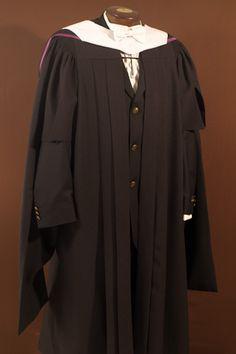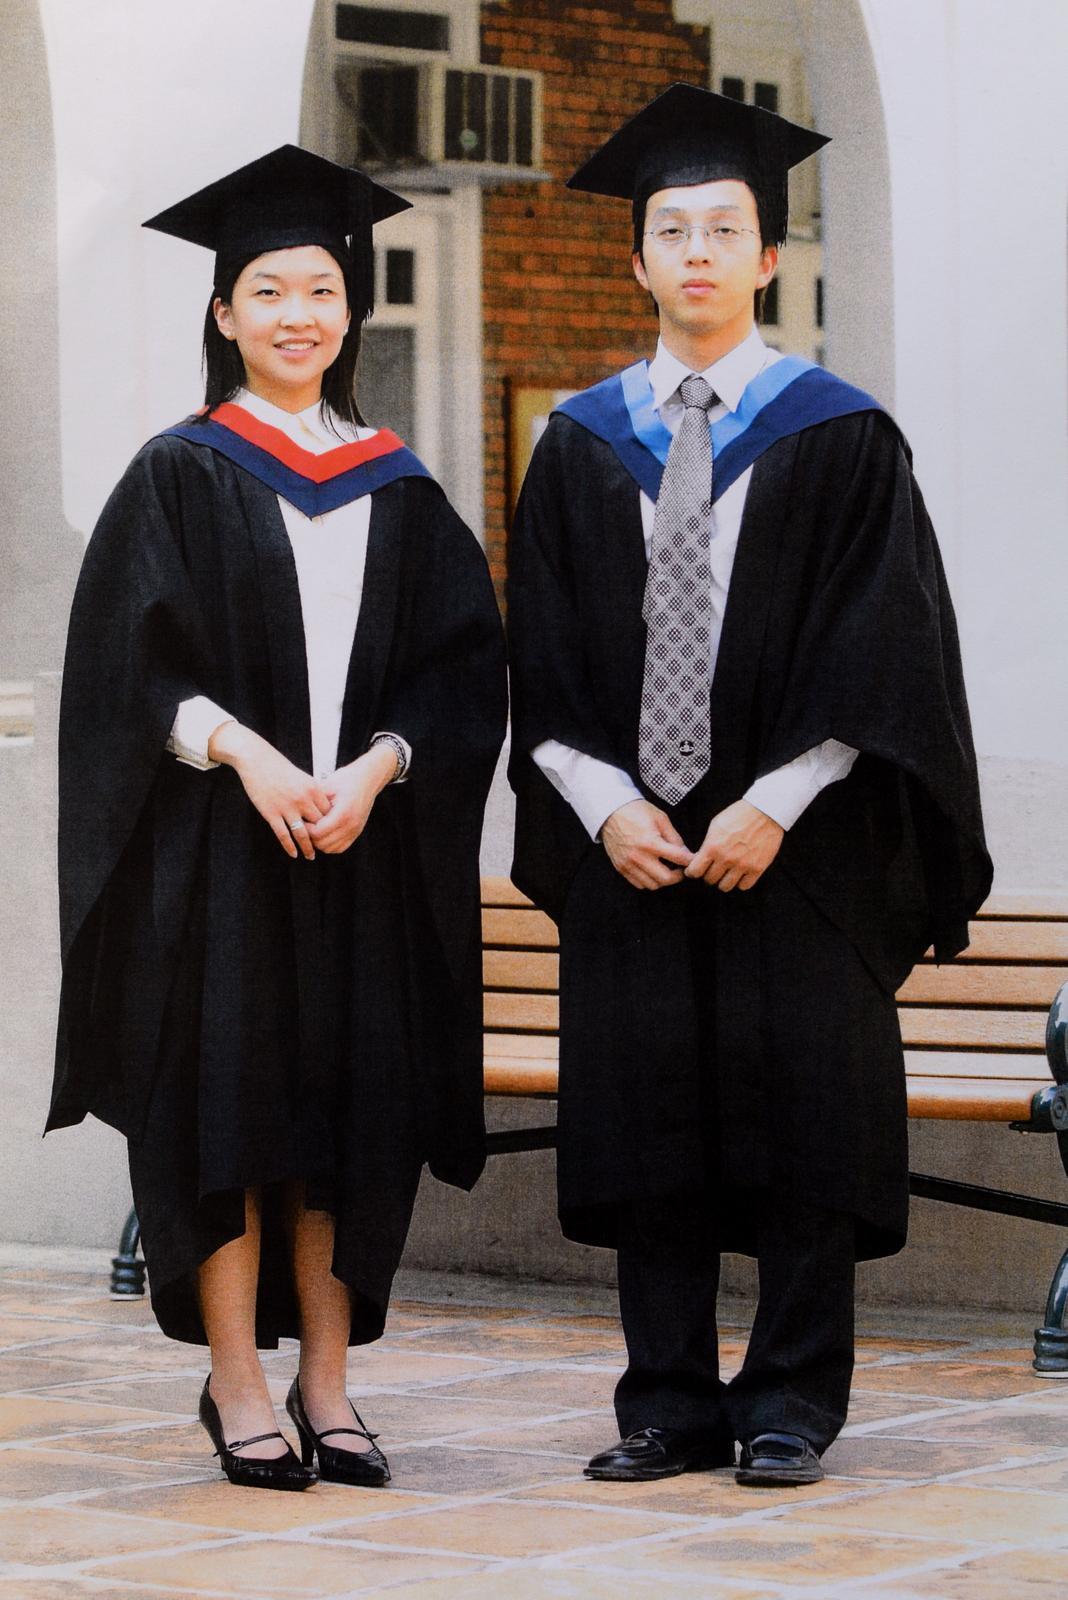The first image is the image on the left, the second image is the image on the right. For the images shown, is this caption "An image shows exactly one black gradulation robe with white embellishments, displayed on a headless form." true? Answer yes or no. Yes. The first image is the image on the left, the second image is the image on the right. Considering the images on both sides, is "There are exactly three graduation robes, two in one image and one in the other, one or more robes does not contain people." valid? Answer yes or no. Yes. 